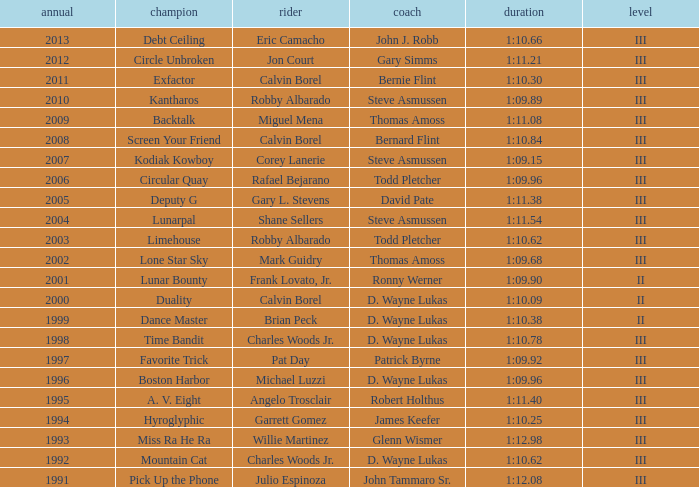Who won under Gary Simms? Circle Unbroken. 